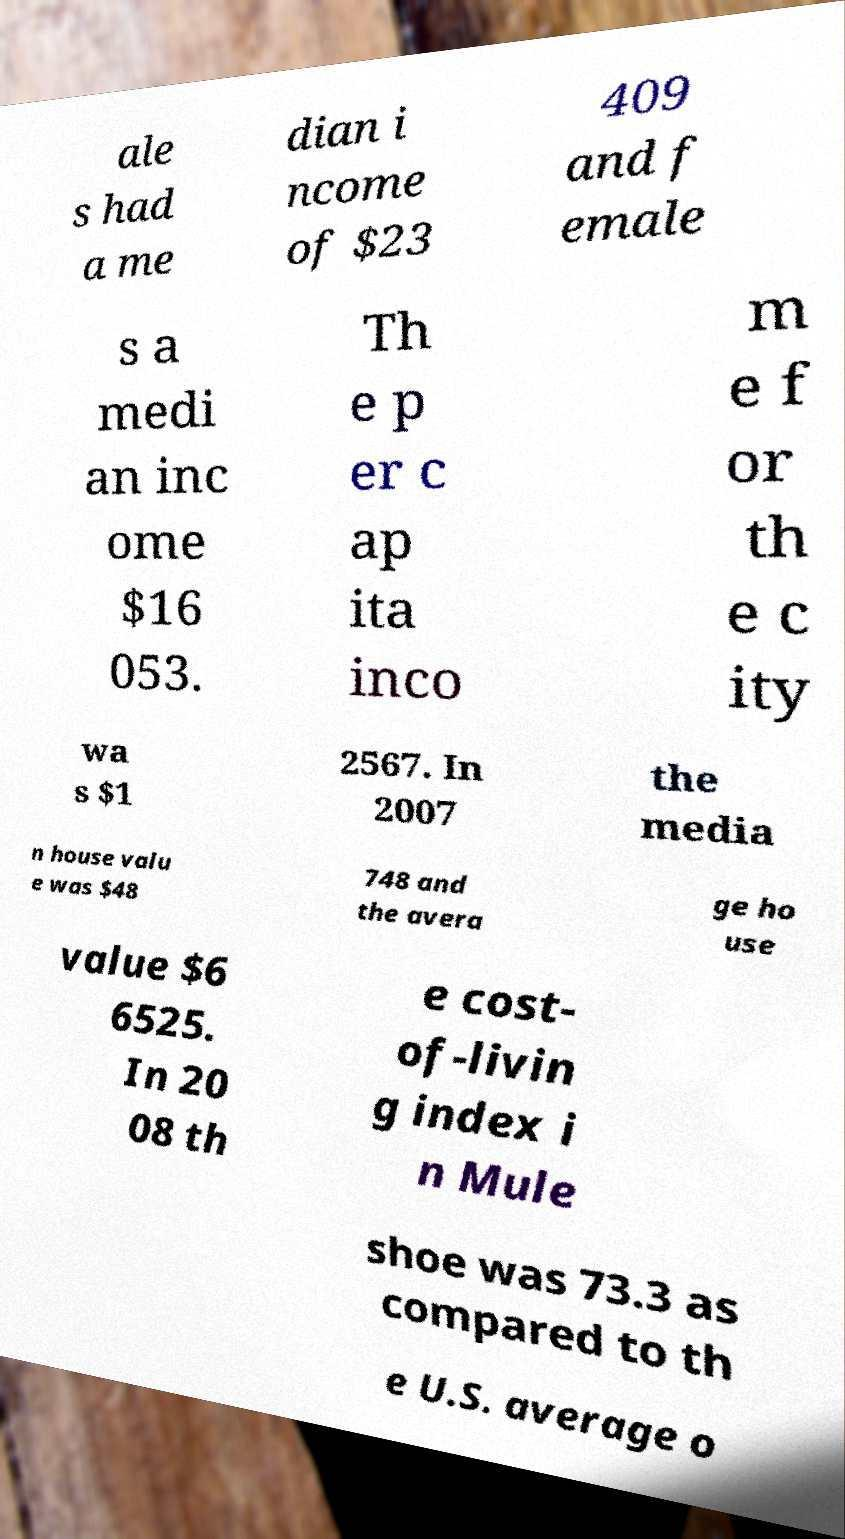I need the written content from this picture converted into text. Can you do that? ale s had a me dian i ncome of $23 409 and f emale s a medi an inc ome $16 053. Th e p er c ap ita inco m e f or th e c ity wa s $1 2567. In 2007 the media n house valu e was $48 748 and the avera ge ho use value $6 6525. In 20 08 th e cost- of-livin g index i n Mule shoe was 73.3 as compared to th e U.S. average o 